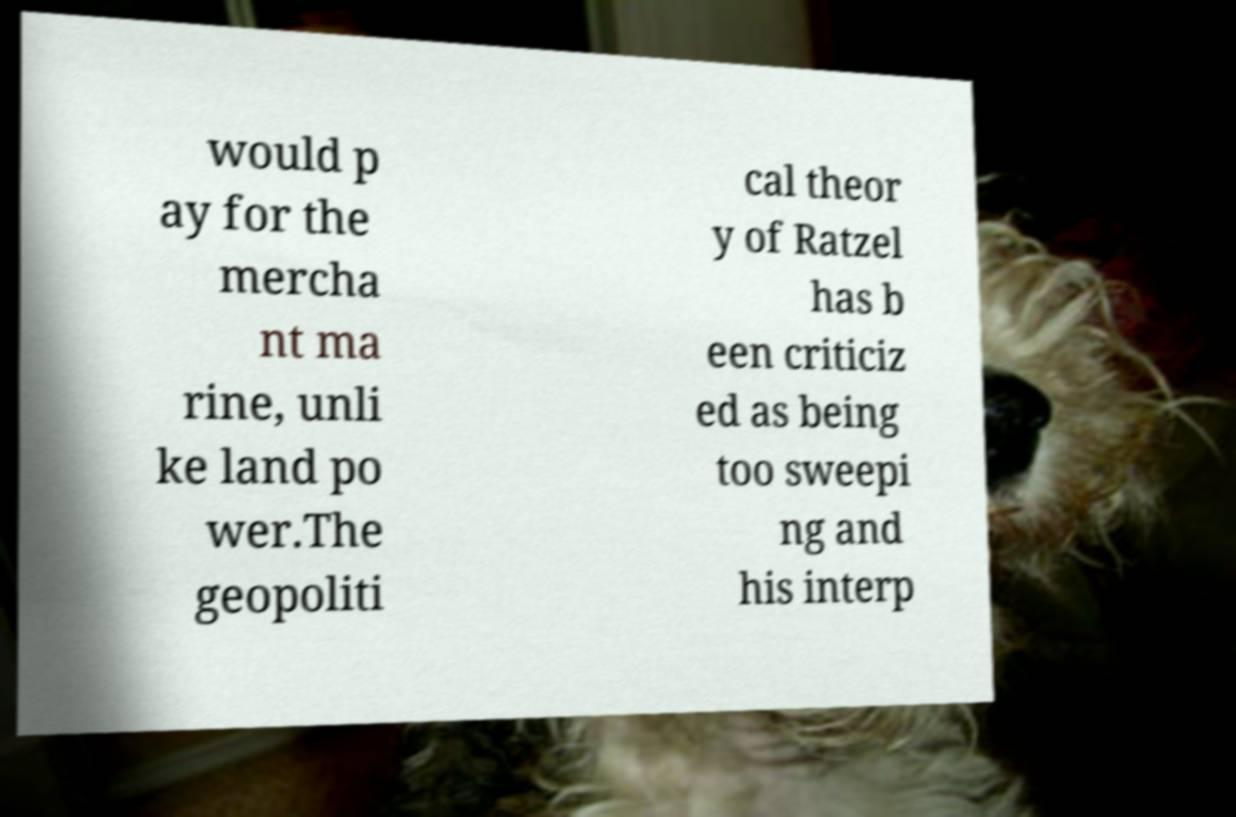Can you accurately transcribe the text from the provided image for me? would p ay for the mercha nt ma rine, unli ke land po wer.The geopoliti cal theor y of Ratzel has b een criticiz ed as being too sweepi ng and his interp 